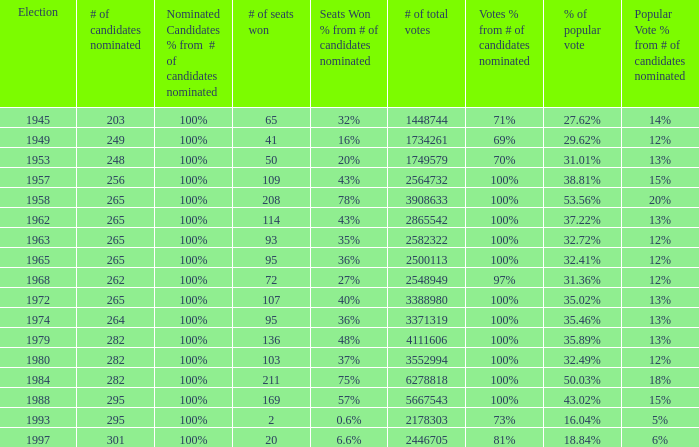How many times was the # of total votes 2582322? 1.0. 